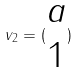Convert formula to latex. <formula><loc_0><loc_0><loc_500><loc_500>v _ { 2 } = ( \begin{matrix} a \\ 1 \end{matrix} )</formula> 